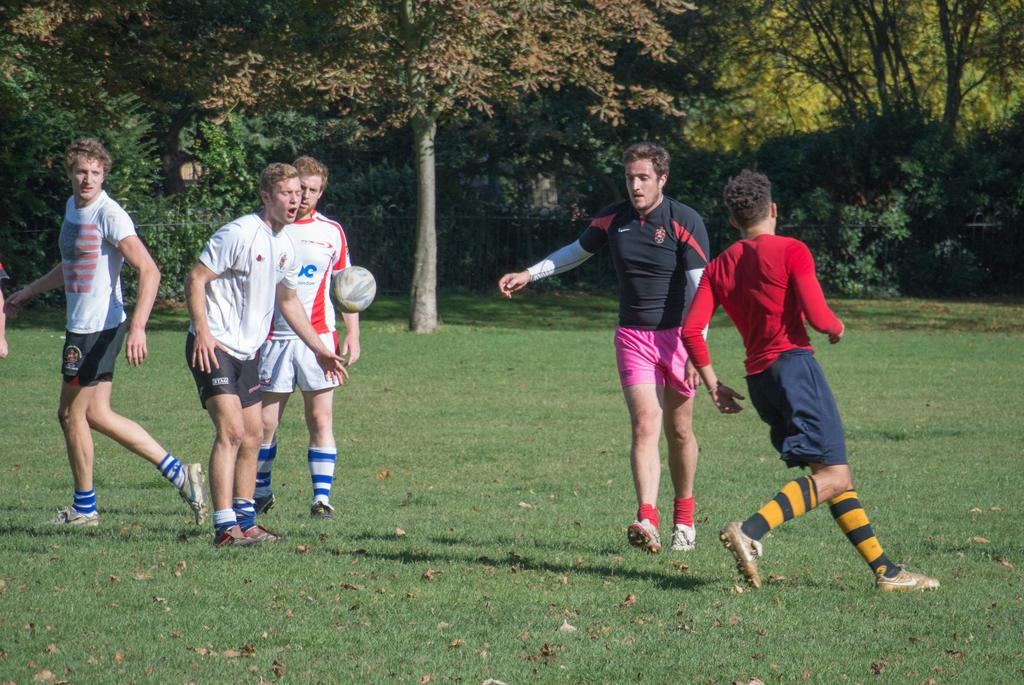How many people are playing football in the image? There are five men in the image. What are the men doing in the image? The men are playing football. What is the surface they are playing on? There is grass at the bottom of the image. What is happening with the ball in the image? There is a ball in the air in the middle of the image. What can be seen in the background of the image? There are trees in the background of the image. What type of discovery was made by the pan in the image? There is no pan present in the image, so no discovery can be made by it. 